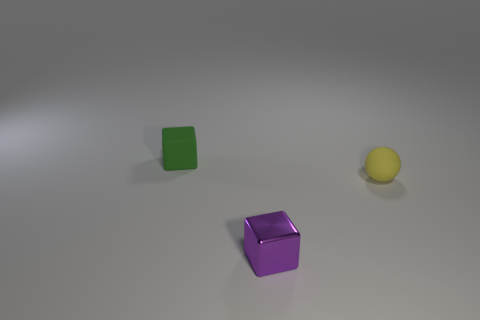There is a small object on the left side of the tiny purple metallic block; what is its color?
Your response must be concise. Green. How many things are either small rubber objects that are behind the tiny yellow matte thing or rubber things in front of the green object?
Your answer should be very brief. 2. Do the rubber block and the sphere have the same size?
Provide a succinct answer. Yes. What number of cubes are green rubber things or big purple metal objects?
Provide a succinct answer. 1. What number of tiny cubes are both behind the yellow object and on the right side of the green block?
Give a very brief answer. 0. There is a tiny block that is on the right side of the small thing that is behind the small yellow rubber sphere; are there any tiny purple metallic objects left of it?
Your answer should be very brief. No. What material is the cube that is in front of the tiny thing behind the yellow thing?
Provide a succinct answer. Metal. There is a small thing that is both behind the purple shiny block and in front of the green thing; what material is it?
Your answer should be compact. Rubber. Is there a small green matte object of the same shape as the small purple thing?
Ensure brevity in your answer.  Yes. There is a block behind the yellow ball; is there a small yellow rubber object behind it?
Provide a succinct answer. No. 